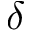Convert formula to latex. <formula><loc_0><loc_0><loc_500><loc_500>\delta</formula> 